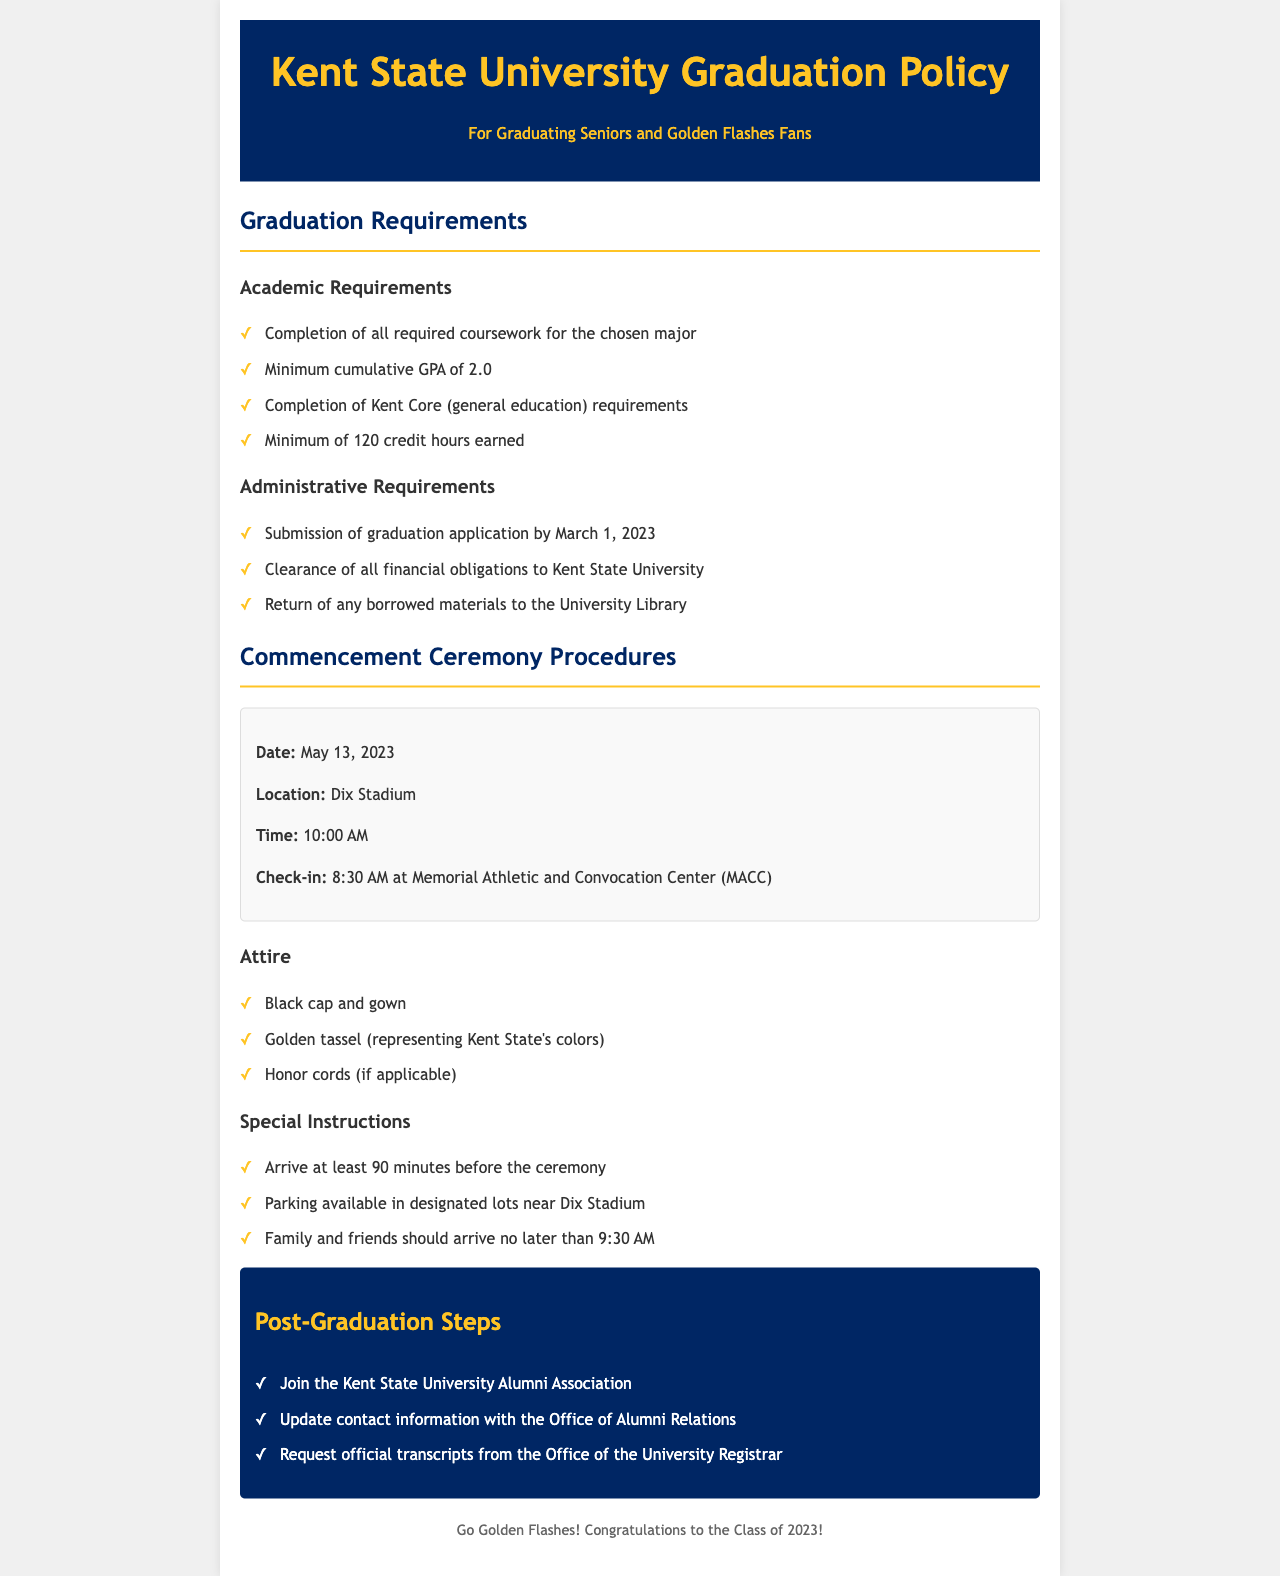What is the date of the commencement ceremony? The date is specified in the ceremony information section of the document.
Answer: May 13, 2023 What is the location of the commencement? The location for the commencement ceremony is mentioned clearly in the document.
Answer: Dix Stadium What is the minimum cumulative GPA required? The requirement for GPA is listed under the academic requirements.
Answer: 2.0 What should graduates wear to the ceremony? The attire requirements for graduates are outlined in the ceremony procedures.
Answer: Black cap and gown When is the check-in time for the ceremony? The check-in time is noted in the ceremony information section.
Answer: 8:30 AM What must be submitted by March 1, 2023? This is a key administrative requirement specified in the document.
Answer: Graduation application When should family and friends arrive? The document details when family and friends should arrive for the ceremony.
Answer: 9:30 AM What is one post-graduation step mentioned? The post-graduation steps are listed; any of them would work as an answer.
Answer: Join the Kent State University Alumni Association What is the time of the commencement ceremony? The time is indicated in the ceremony information section.
Answer: 10:00 AM 